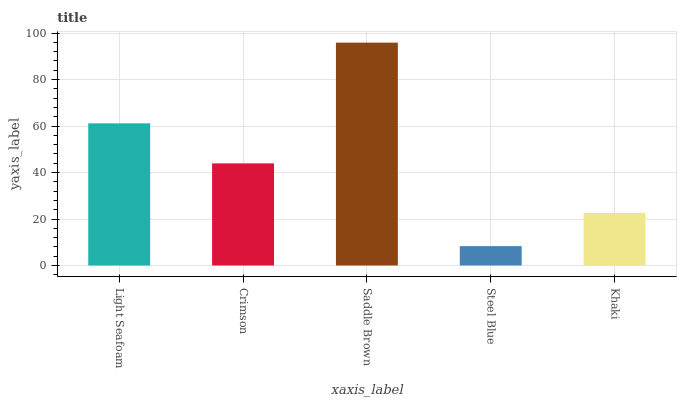Is Steel Blue the minimum?
Answer yes or no. Yes. Is Saddle Brown the maximum?
Answer yes or no. Yes. Is Crimson the minimum?
Answer yes or no. No. Is Crimson the maximum?
Answer yes or no. No. Is Light Seafoam greater than Crimson?
Answer yes or no. Yes. Is Crimson less than Light Seafoam?
Answer yes or no. Yes. Is Crimson greater than Light Seafoam?
Answer yes or no. No. Is Light Seafoam less than Crimson?
Answer yes or no. No. Is Crimson the high median?
Answer yes or no. Yes. Is Crimson the low median?
Answer yes or no. Yes. Is Light Seafoam the high median?
Answer yes or no. No. Is Khaki the low median?
Answer yes or no. No. 